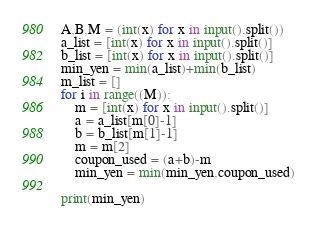Convert code to text. <code><loc_0><loc_0><loc_500><loc_500><_Python_>A,B,M = (int(x) for x in input().split())
a_list = [int(x) for x in input().split()]
b_list = [int(x) for x in input().split()]
min_yen = min(a_list)+min(b_list)
m_list = []
for i in range((M)):
    m = [int(x) for x in input().split()]
    a = a_list[m[0]-1]
    b = b_list[m[1]-1]
    m = m[2]
    coupon_used = (a+b)-m
    min_yen = min(min_yen,coupon_used)    

print(min_yen)</code> 